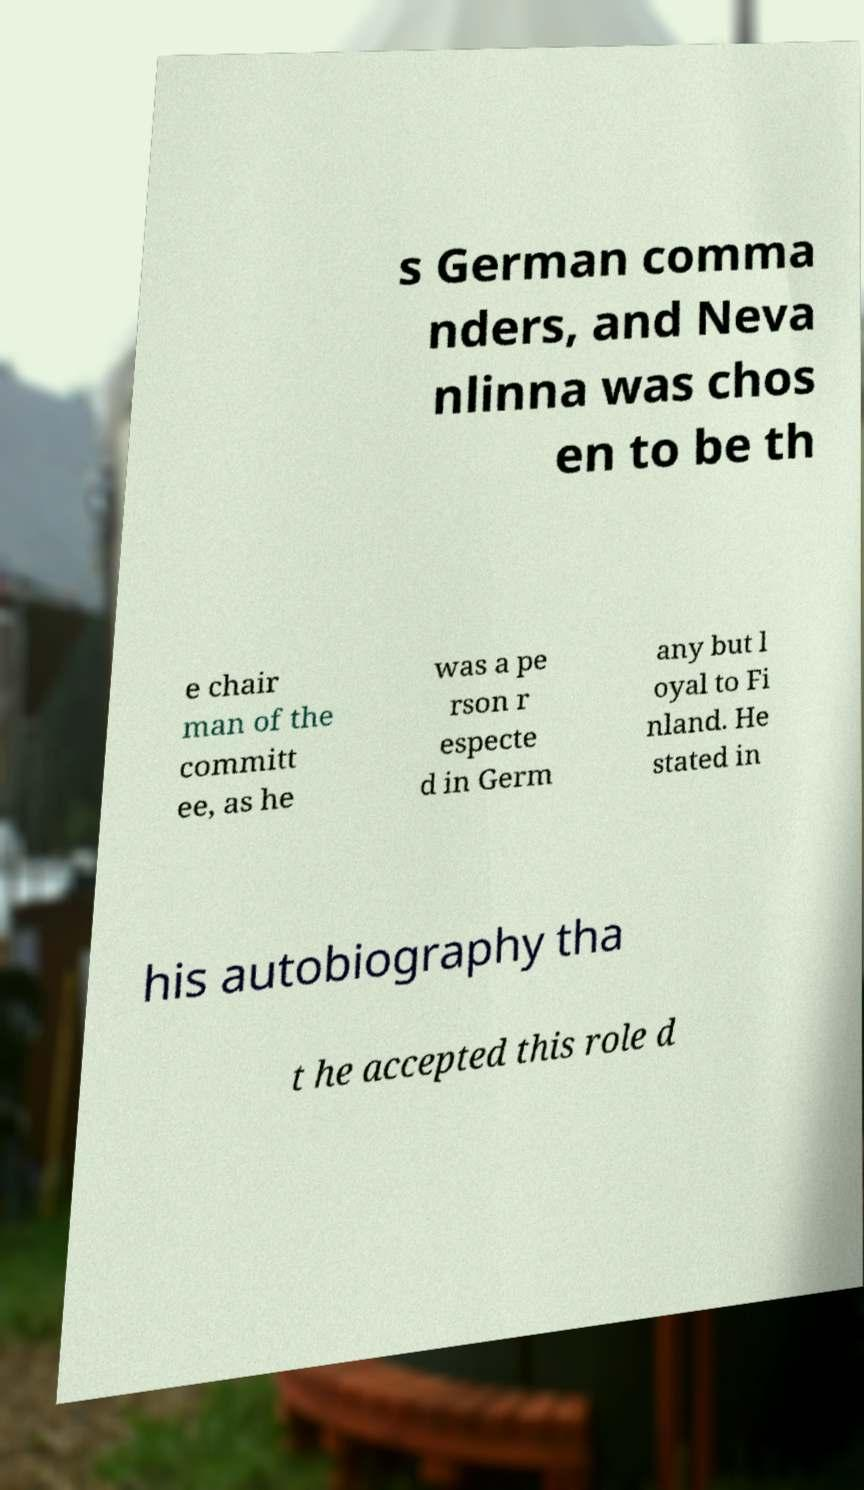Please identify and transcribe the text found in this image. s German comma nders, and Neva nlinna was chos en to be th e chair man of the committ ee, as he was a pe rson r especte d in Germ any but l oyal to Fi nland. He stated in his autobiography tha t he accepted this role d 